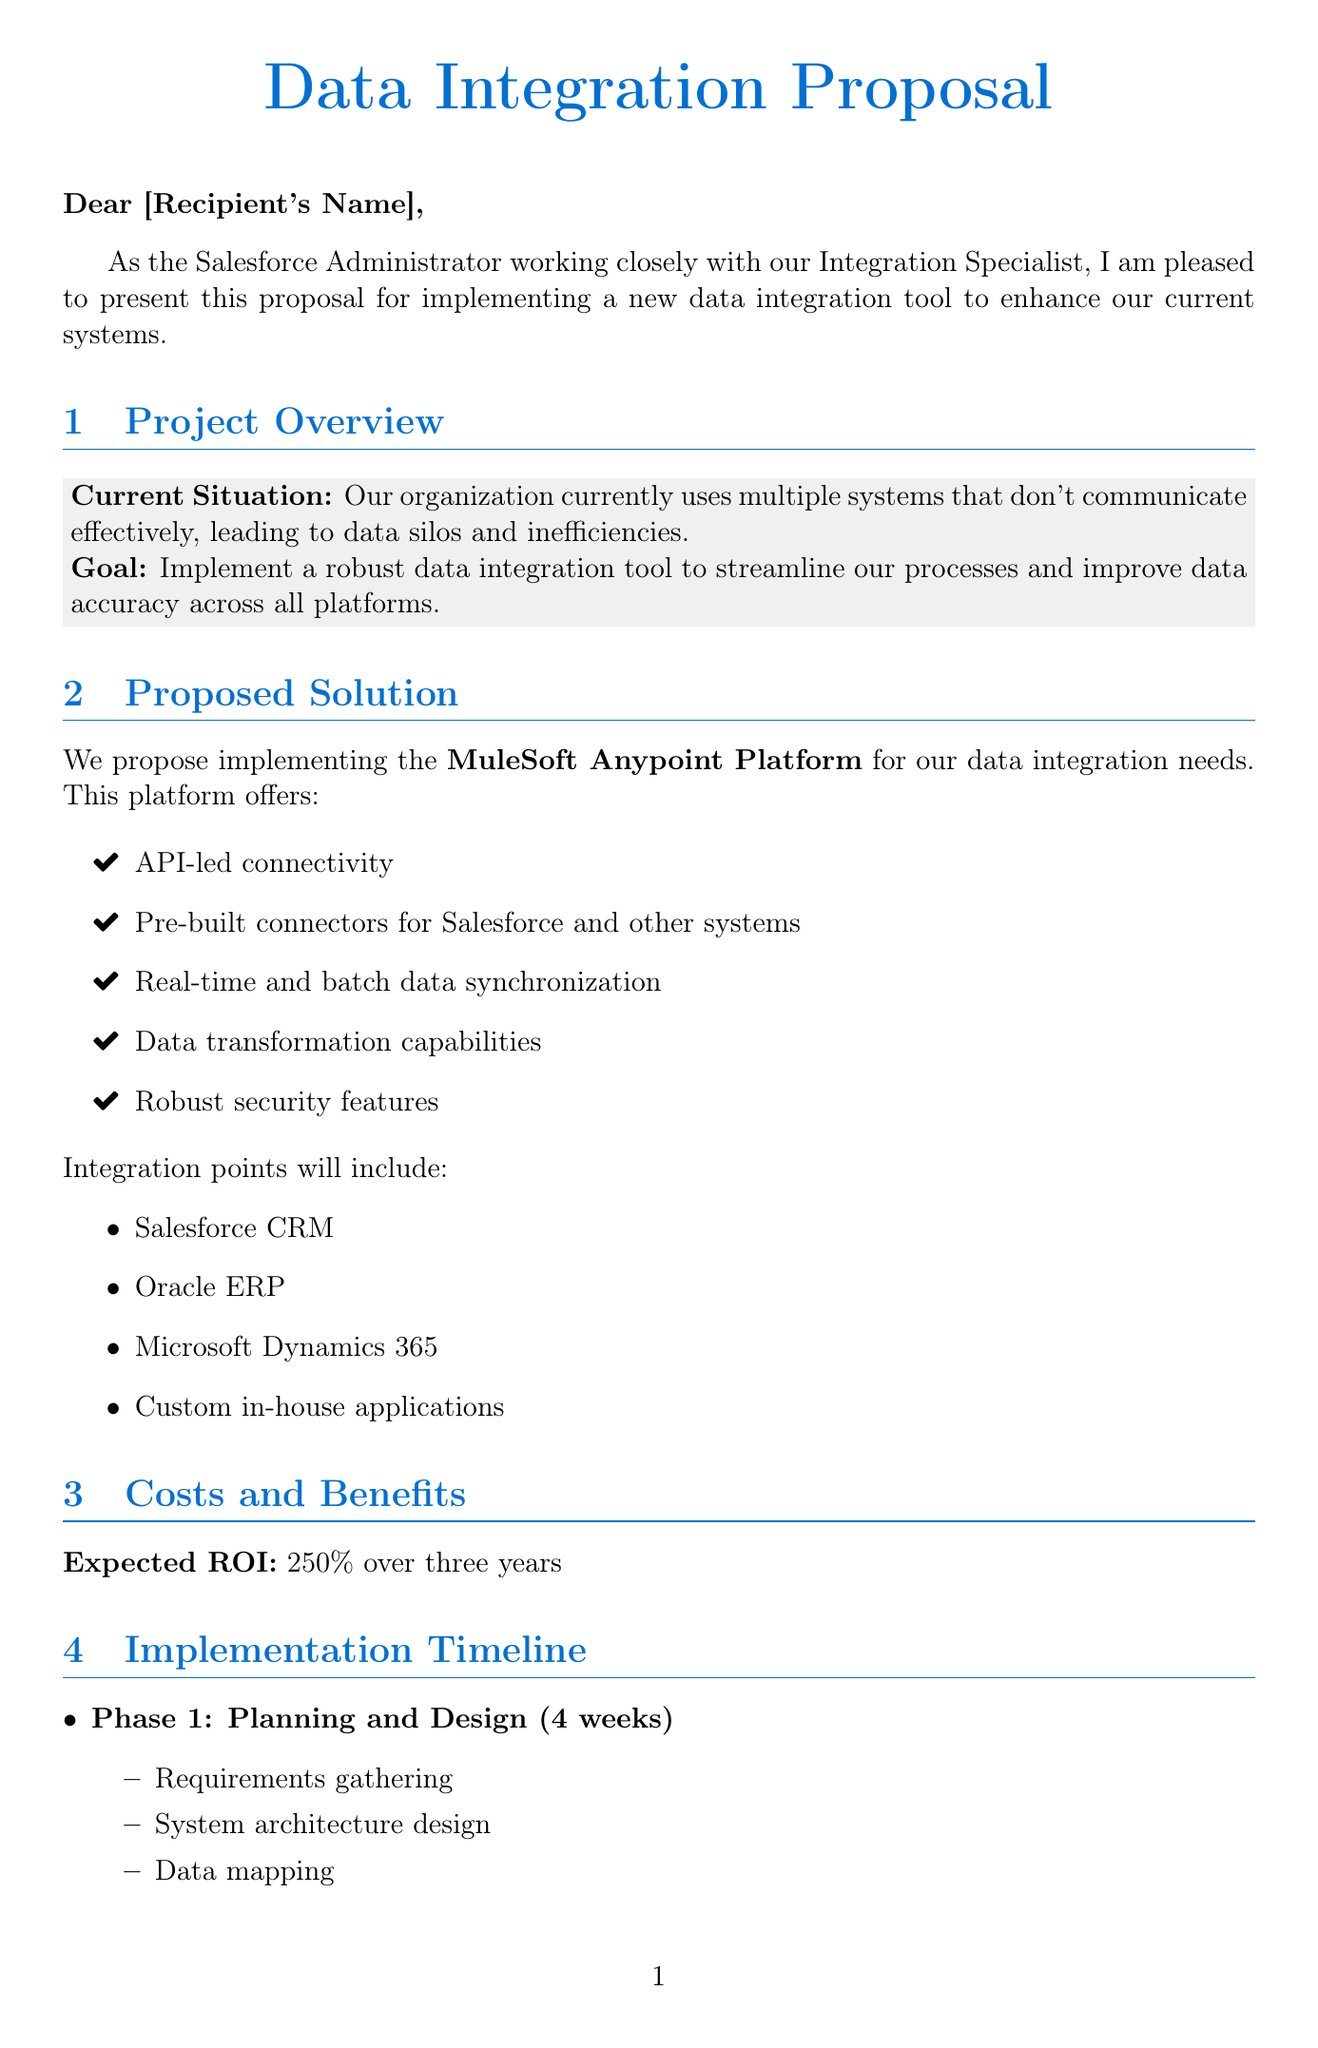what is the proposed integration tool? The proposed tool is specifically mentioned in the document as the MuleSoft Anypoint Platform.
Answer: MuleSoft Anypoint Platform how much is the annual licensing cost? The licensing cost is explicitly listed in the document as annual licensing expenses.
Answer: $150,000 per year what is the expected ROI over three years? The document provides an estimate of return on investment over a defined period, which is specified clearly.
Answer: 250% how many weeks are allocated for the Development and Testing phase? The duration of the Development and Testing phase is provided in the timeline section, indicating the length of this phase.
Answer: 8 weeks what is one key benefit of implementing the new tool? The document outlines several benefits; one of them can be referenced directly from the benefits section.
Answer: 30% reduction in manual data entry who should review and approve the proposal? The document indicates who is responsible for the review and approval process, delineating the next steps.
Answer: stakeholders what is the name of the first phase in the implementation timeline? The first phase is mentioned with a distinct title in the implementation timeline of the document.
Answer: Planning and Design which in-house applications will be integrated? The document lists integration points; it does not specify exactly what these custom applications are but refers to them.
Answer: Custom in-house applications how much is budgeted for staff training? The training cost is specified clearly in the costs section of the document, representing the budget allocation.
Answer: $25,000 